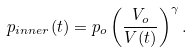<formula> <loc_0><loc_0><loc_500><loc_500>p _ { i n n e r } ( t ) = p _ { o } \left ( \frac { V _ { o } } { V ( t ) } \right ) ^ { \gamma } .</formula> 